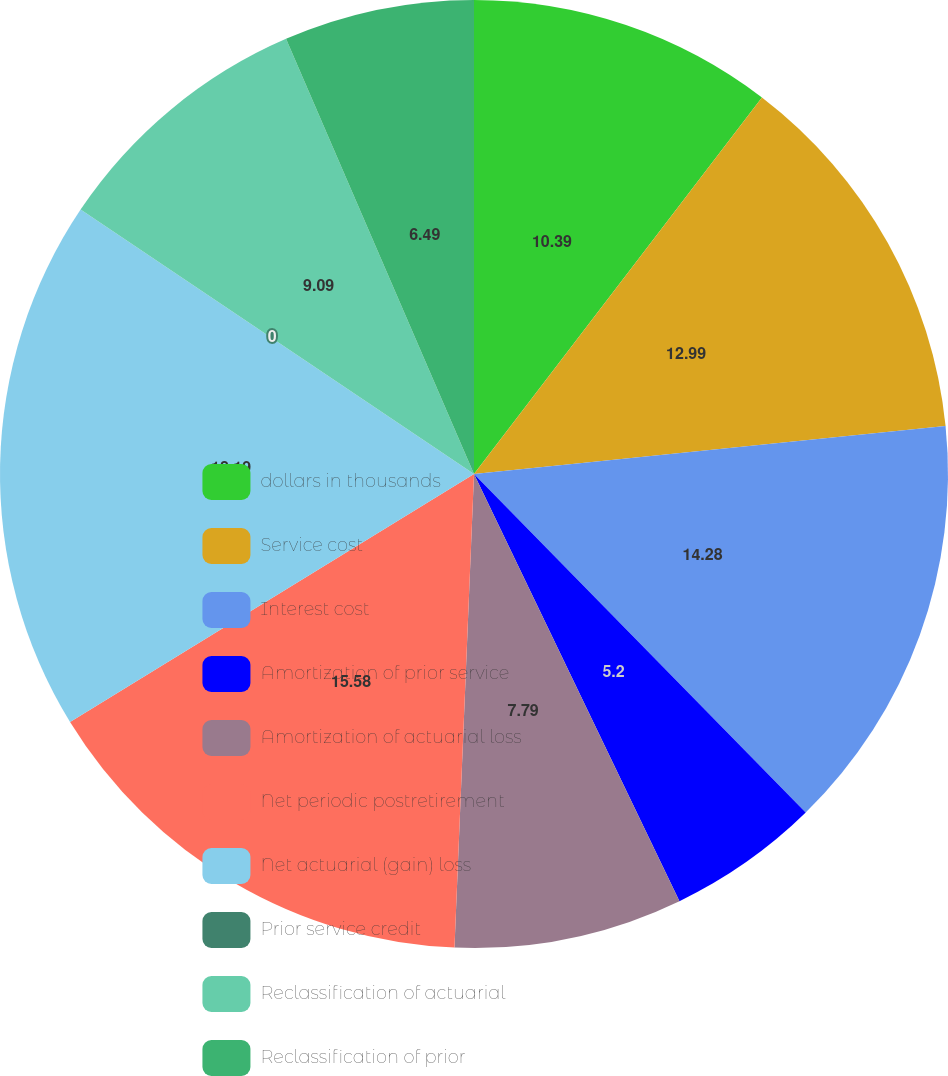<chart> <loc_0><loc_0><loc_500><loc_500><pie_chart><fcel>dollars in thousands<fcel>Service cost<fcel>Interest cost<fcel>Amortization of prior service<fcel>Amortization of actuarial loss<fcel>Net periodic postretirement<fcel>Net actuarial (gain) loss<fcel>Prior service credit<fcel>Reclassification of actuarial<fcel>Reclassification of prior<nl><fcel>10.39%<fcel>12.99%<fcel>14.28%<fcel>5.2%<fcel>7.79%<fcel>15.58%<fcel>18.18%<fcel>0.0%<fcel>9.09%<fcel>6.49%<nl></chart> 